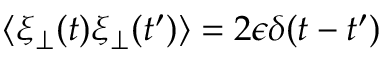Convert formula to latex. <formula><loc_0><loc_0><loc_500><loc_500>\langle \xi _ { \perp } ( t ) \xi _ { \perp } ( t ^ { \prime } ) \rangle = 2 \epsilon \delta ( t - t ^ { \prime } )</formula> 